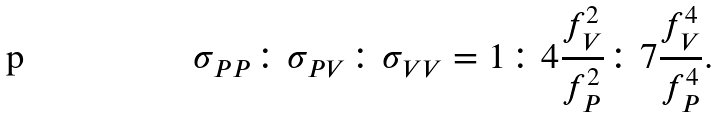<formula> <loc_0><loc_0><loc_500><loc_500>\sigma _ { P P } \colon \sigma _ { P V } \colon \sigma _ { V V } = 1 \colon 4 \frac { f ^ { 2 } _ { V } } { f ^ { 2 } _ { P } } \colon 7 \frac { f ^ { 4 } _ { V } } { f ^ { 4 } _ { P } } .</formula> 